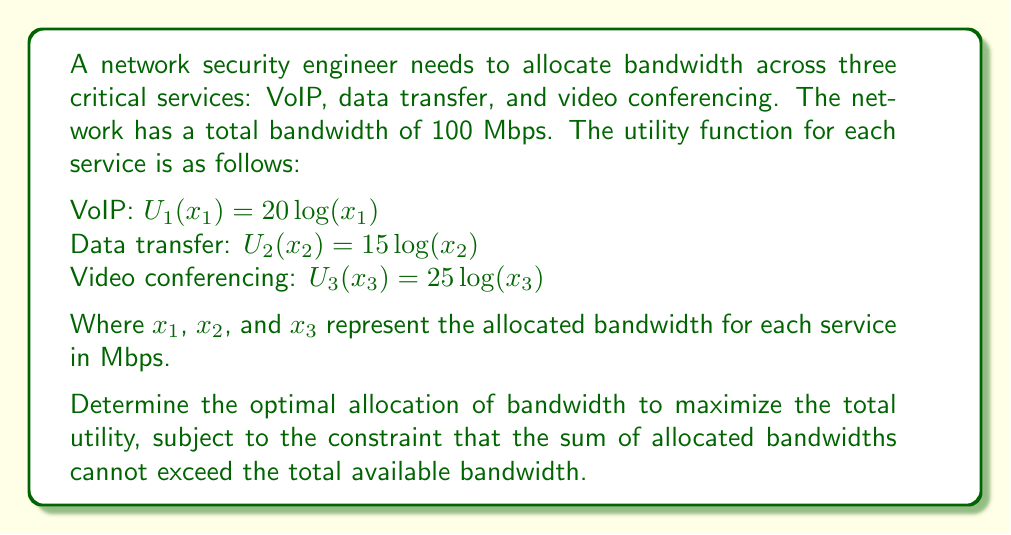Can you answer this question? To solve this optimization problem, we'll use the method of Lagrange multipliers:

1. Define the objective function:
   $U(x_1, x_2, x_3) = 20 \log(x_1) + 15 \log(x_2) + 25 \log(x_3)$

2. Define the constraint:
   $g(x_1, x_2, x_3) = x_1 + x_2 + x_3 - 100 = 0$

3. Form the Lagrangian:
   $L(x_1, x_2, x_3, \lambda) = 20 \log(x_1) + 15 \log(x_2) + 25 \log(x_3) - \lambda(x_1 + x_2 + x_3 - 100)$

4. Take partial derivatives and set them to zero:
   $\frac{\partial L}{\partial x_1} = \frac{20}{x_1} - \lambda = 0$
   $\frac{\partial L}{\partial x_2} = \frac{15}{x_2} - \lambda = 0$
   $\frac{\partial L}{\partial x_3} = \frac{25}{x_3} - \lambda = 0$
   $\frac{\partial L}{\partial \lambda} = x_1 + x_2 + x_3 - 100 = 0$

5. From these equations, we can derive:
   $x_1 = \frac{20}{\lambda}$
   $x_2 = \frac{15}{\lambda}$
   $x_3 = \frac{25}{\lambda}$

6. Substitute these into the constraint equation:
   $\frac{20}{\lambda} + \frac{15}{\lambda} + \frac{25}{\lambda} = 100$
   $\frac{60}{\lambda} = 100$
   $\lambda = \frac{60}{100} = 0.6$

7. Now we can solve for $x_1$, $x_2$, and $x_3$:
   $x_1 = \frac{20}{0.6} = 33.33$ Mbps
   $x_2 = \frac{15}{0.6} = 25$ Mbps
   $x_3 = \frac{25}{0.6} = 41.67$ Mbps

8. Verify that the sum of allocated bandwidths equals the total available bandwidth:
   $33.33 + 25 + 41.67 = 100$ Mbps
Answer: The optimal allocation of bandwidth to maximize total utility is:
VoIP (x_1): 33.33 Mbps
Data transfer (x_2): 25 Mbps
Video conferencing (x_3): 41.67 Mbps 